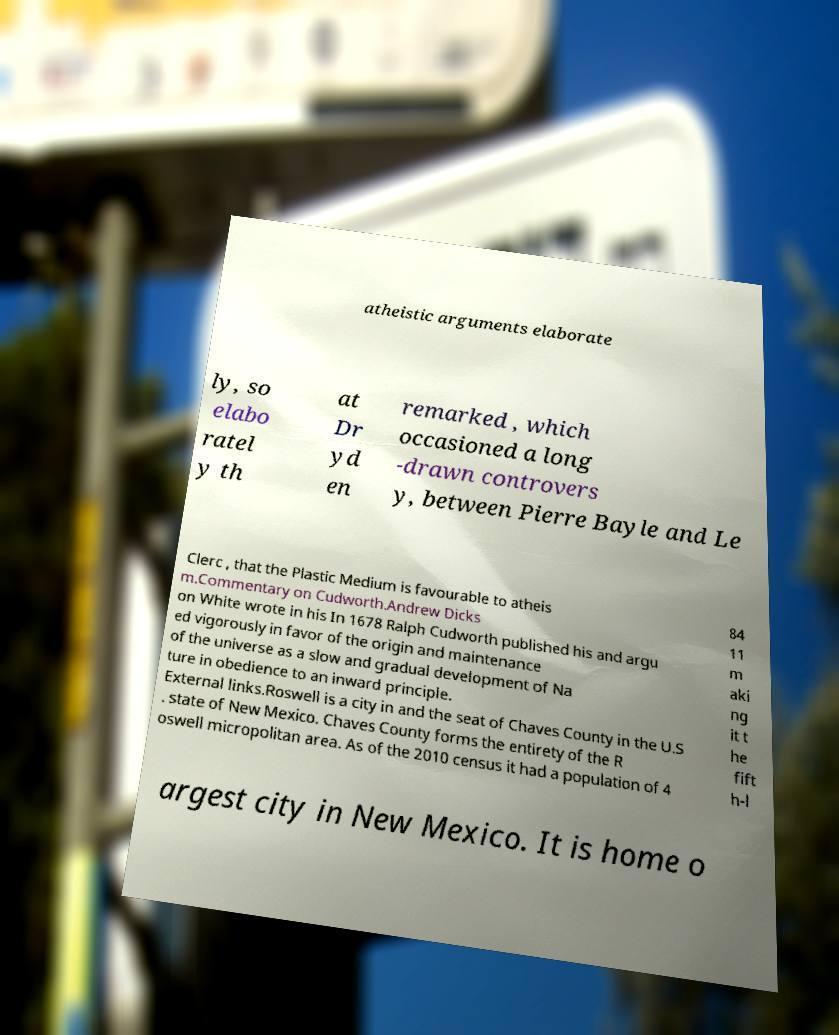Can you accurately transcribe the text from the provided image for me? atheistic arguments elaborate ly, so elabo ratel y th at Dr yd en remarked , which occasioned a long -drawn controvers y, between Pierre Bayle and Le Clerc , that the Plastic Medium is favourable to atheis m.Commentary on Cudworth.Andrew Dicks on White wrote in his In 1678 Ralph Cudworth published his and argu ed vigorously in favor of the origin and maintenance of the universe as a slow and gradual development of Na ture in obedience to an inward principle. External links.Roswell is a city in and the seat of Chaves County in the U.S . state of New Mexico. Chaves County forms the entirety of the R oswell micropolitan area. As of the 2010 census it had a population of 4 84 11 m aki ng it t he fift h-l argest city in New Mexico. It is home o 